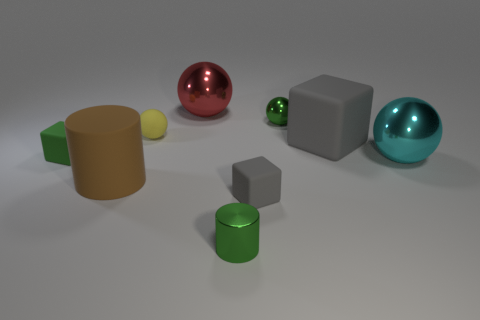Subtract 1 spheres. How many spheres are left? 3 Subtract all yellow balls. How many balls are left? 3 Add 1 balls. How many objects exist? 10 Subtract all blue balls. Subtract all red cylinders. How many balls are left? 4 Subtract all cylinders. How many objects are left? 7 Subtract all tiny brown shiny cylinders. Subtract all large gray blocks. How many objects are left? 8 Add 6 big red shiny objects. How many big red shiny objects are left? 7 Add 6 tiny yellow rubber objects. How many tiny yellow rubber objects exist? 7 Subtract 1 green spheres. How many objects are left? 8 